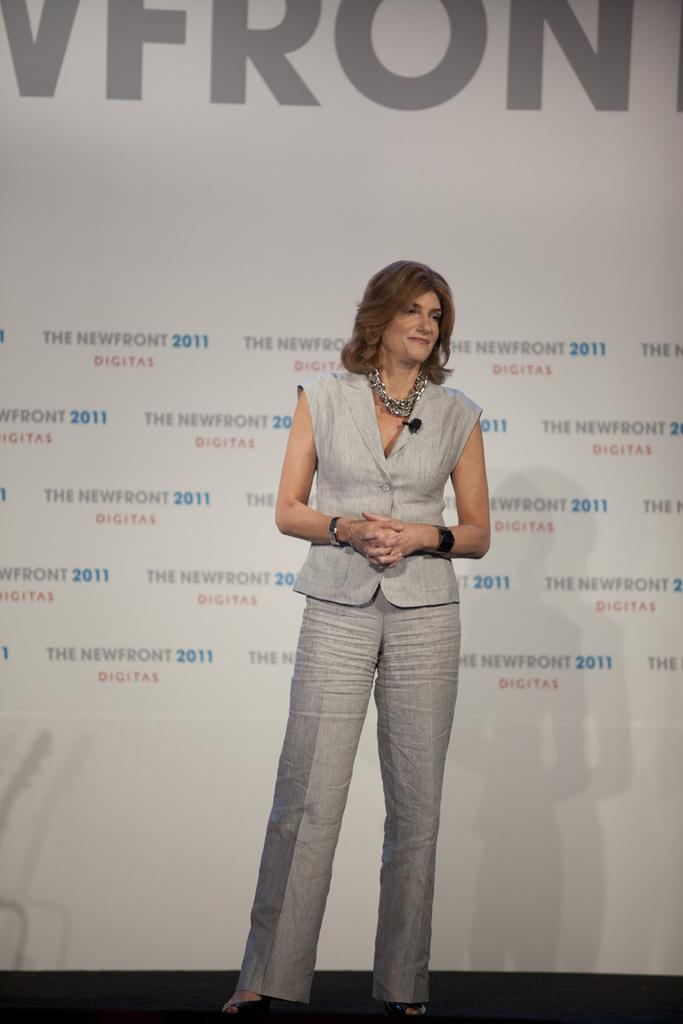What is the main subject of the image? There is a person standing in the image. Can you describe the person's clothing? The person is wearing an ash-colored dress. What can be seen in the background of the image? There is a screen visible in the background of the image. How many rabbits are hopping around the person's feet in the image? There are no rabbits present in the image. What type of cake is the person holding in the image? There is no cake present in the image. 